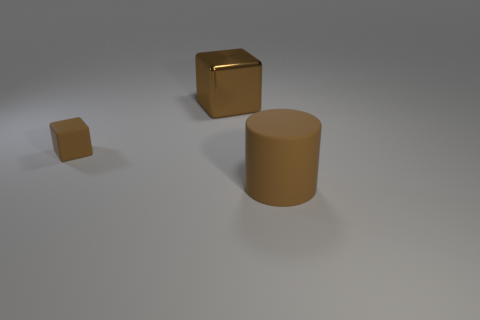How many small brown objects are the same shape as the large brown matte thing?
Offer a very short reply. 0. How big is the brown rubber object that is on the left side of the brown rubber thing in front of the brown matte object that is behind the big matte object?
Provide a succinct answer. Small. Are there more tiny brown matte blocks to the left of the brown metallic block than small matte cylinders?
Ensure brevity in your answer.  Yes. Is there a cyan object?
Your answer should be compact. No. What number of green metallic balls have the same size as the brown metallic cube?
Keep it short and to the point. 0. Is the number of big brown cylinders left of the cylinder greater than the number of large brown cubes to the left of the metallic thing?
Make the answer very short. No. What material is the thing that is the same size as the brown matte cylinder?
Ensure brevity in your answer.  Metal. What is the shape of the big rubber object?
Ensure brevity in your answer.  Cylinder. How many blue objects are either small rubber things or matte cylinders?
Give a very brief answer. 0. What is the size of the brown cylinder that is the same material as the small brown cube?
Provide a succinct answer. Large. 